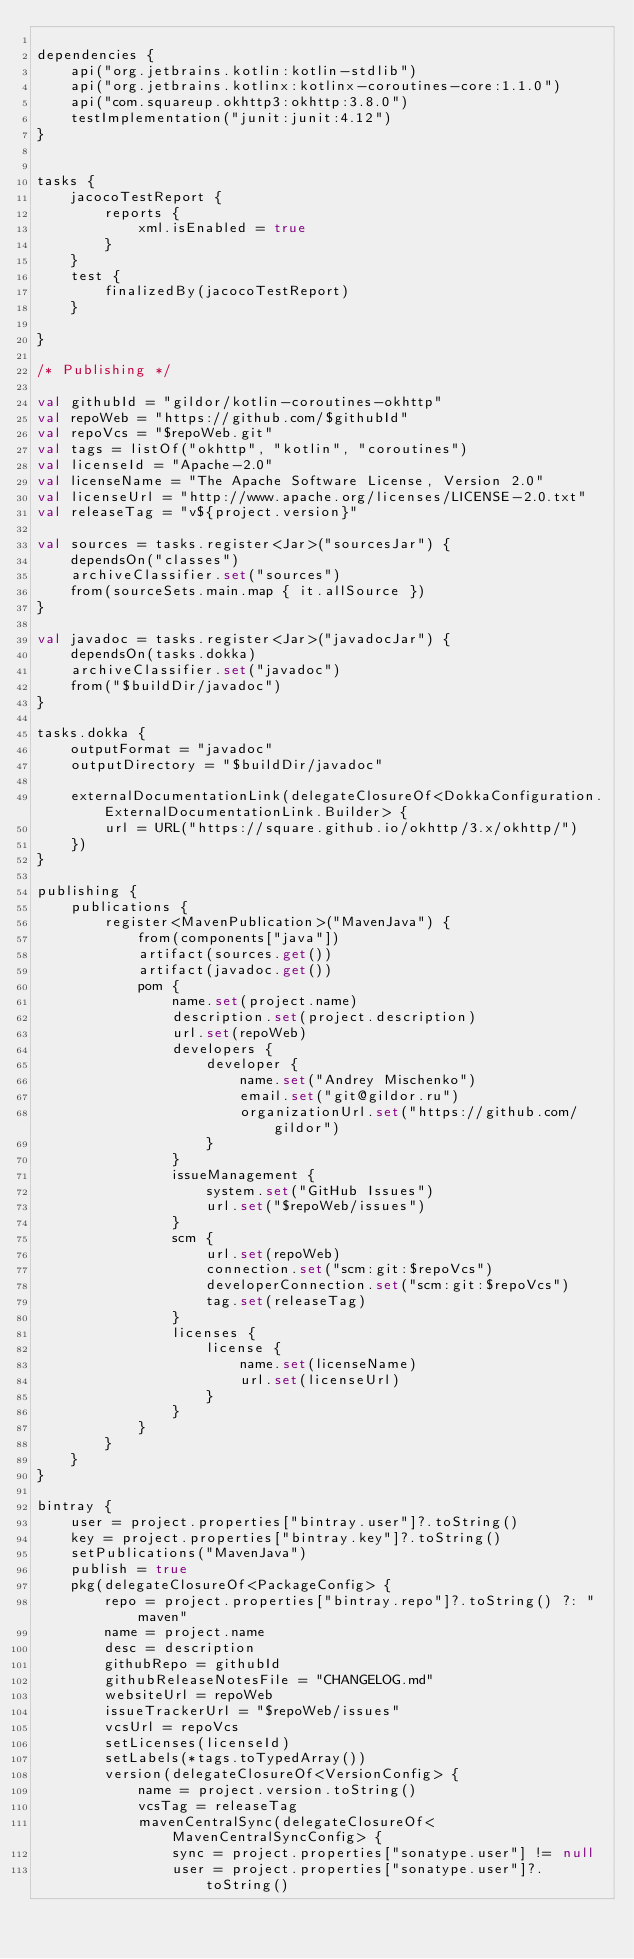Convert code to text. <code><loc_0><loc_0><loc_500><loc_500><_Kotlin_>
dependencies {
    api("org.jetbrains.kotlin:kotlin-stdlib")
    api("org.jetbrains.kotlinx:kotlinx-coroutines-core:1.1.0")
    api("com.squareup.okhttp3:okhttp:3.8.0")
    testImplementation("junit:junit:4.12")
}


tasks {
    jacocoTestReport {
        reports {
            xml.isEnabled = true
        }
    }
    test {
        finalizedBy(jacocoTestReport)
    }

}

/* Publishing */

val githubId = "gildor/kotlin-coroutines-okhttp"
val repoWeb = "https://github.com/$githubId"
val repoVcs = "$repoWeb.git"
val tags = listOf("okhttp", "kotlin", "coroutines")
val licenseId = "Apache-2.0"
val licenseName = "The Apache Software License, Version 2.0"
val licenseUrl = "http://www.apache.org/licenses/LICENSE-2.0.txt"
val releaseTag = "v${project.version}"

val sources = tasks.register<Jar>("sourcesJar") {
    dependsOn("classes")
    archiveClassifier.set("sources")
    from(sourceSets.main.map { it.allSource })
}

val javadoc = tasks.register<Jar>("javadocJar") {
    dependsOn(tasks.dokka)
    archiveClassifier.set("javadoc")
    from("$buildDir/javadoc")
}

tasks.dokka {
    outputFormat = "javadoc"
    outputDirectory = "$buildDir/javadoc"

    externalDocumentationLink(delegateClosureOf<DokkaConfiguration.ExternalDocumentationLink.Builder> {
        url = URL("https://square.github.io/okhttp/3.x/okhttp/")
    })
}

publishing {
    publications {
        register<MavenPublication>("MavenJava") {
            from(components["java"])
            artifact(sources.get())
            artifact(javadoc.get())
            pom {
                name.set(project.name)
                description.set(project.description)
                url.set(repoWeb)
                developers {
                    developer {
                        name.set("Andrey Mischenko")
                        email.set("git@gildor.ru")
                        organizationUrl.set("https://github.com/gildor")
                    }
                }
                issueManagement {
                    system.set("GitHub Issues")
                    url.set("$repoWeb/issues")
                }
                scm {
                    url.set(repoWeb)
                    connection.set("scm:git:$repoVcs")
                    developerConnection.set("scm:git:$repoVcs")
                    tag.set(releaseTag)
                }
                licenses {
                    license {
                        name.set(licenseName)
                        url.set(licenseUrl)
                    }
                }
            }
        }
    }
}

bintray {
    user = project.properties["bintray.user"]?.toString()
    key = project.properties["bintray.key"]?.toString()
    setPublications("MavenJava")
    publish = true
    pkg(delegateClosureOf<PackageConfig> {
        repo = project.properties["bintray.repo"]?.toString() ?: "maven"
        name = project.name
        desc = description
        githubRepo = githubId
        githubReleaseNotesFile = "CHANGELOG.md"
        websiteUrl = repoWeb
        issueTrackerUrl = "$repoWeb/issues"
        vcsUrl = repoVcs
        setLicenses(licenseId)
        setLabels(*tags.toTypedArray())
        version(delegateClosureOf<VersionConfig> {
            name = project.version.toString()
            vcsTag = releaseTag
            mavenCentralSync(delegateClosureOf<MavenCentralSyncConfig> {
                sync = project.properties["sonatype.user"] != null
                user = project.properties["sonatype.user"]?.toString()</code> 